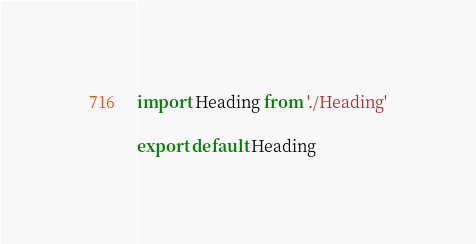Convert code to text. <code><loc_0><loc_0><loc_500><loc_500><_JavaScript_>import Heading from './Heading'

export default Heading
</code> 